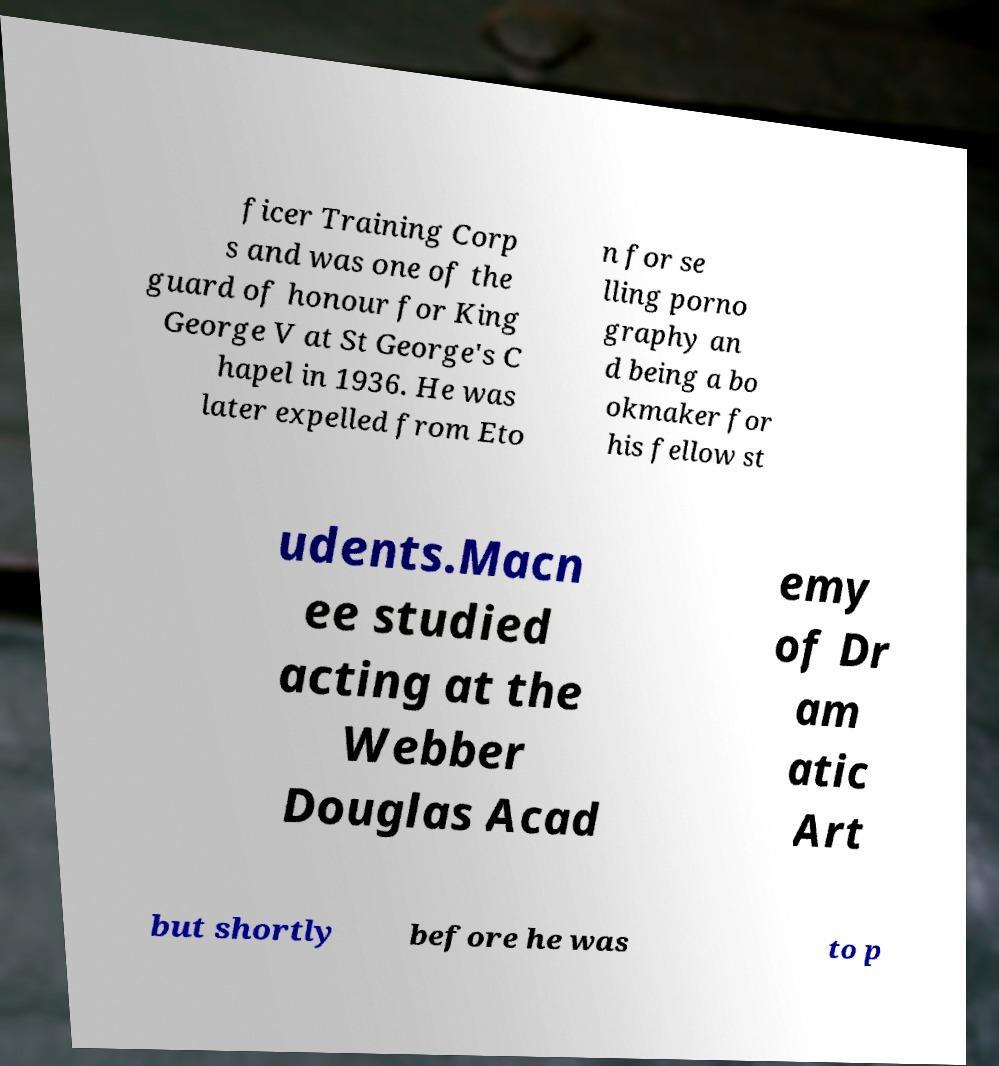Please read and relay the text visible in this image. What does it say? ficer Training Corp s and was one of the guard of honour for King George V at St George's C hapel in 1936. He was later expelled from Eto n for se lling porno graphy an d being a bo okmaker for his fellow st udents.Macn ee studied acting at the Webber Douglas Acad emy of Dr am atic Art but shortly before he was to p 